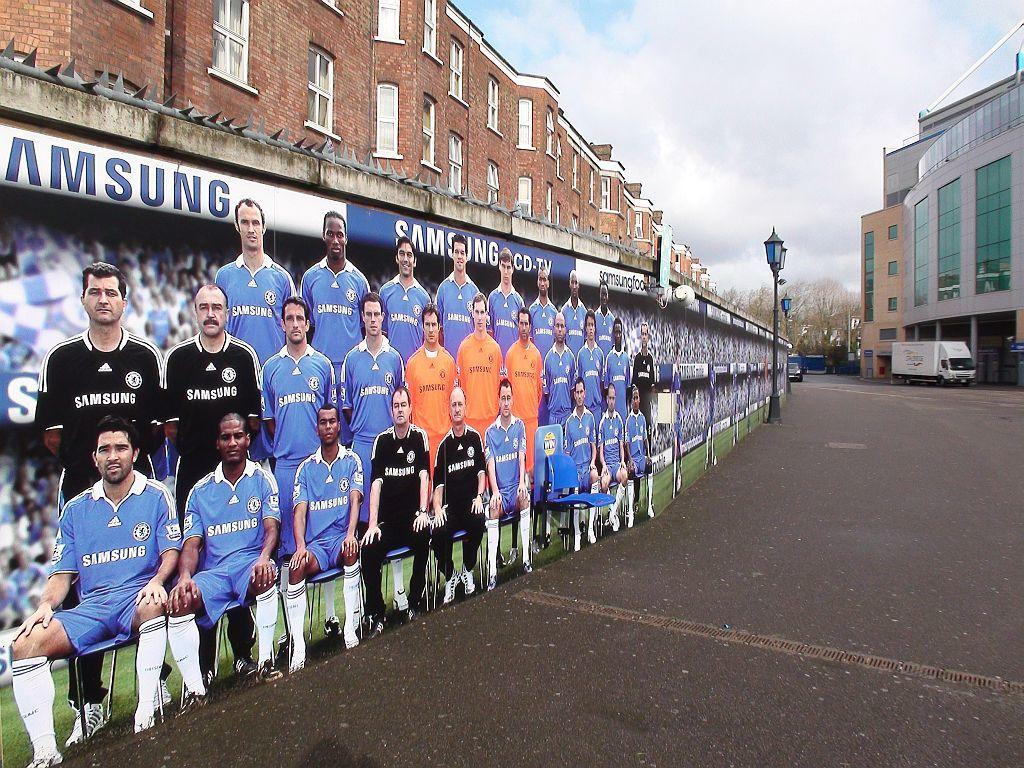<image>
Write a terse but informative summary of the picture. A group of soccer players in front of a Samsung sign 